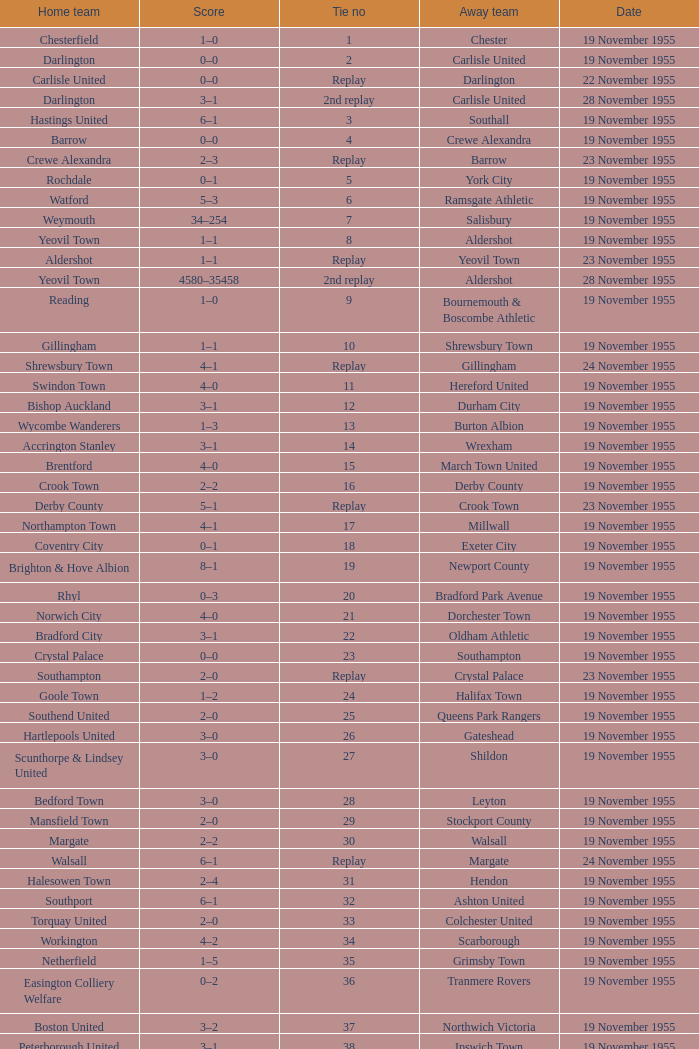What is the away team with a 5 tie no? York City. 